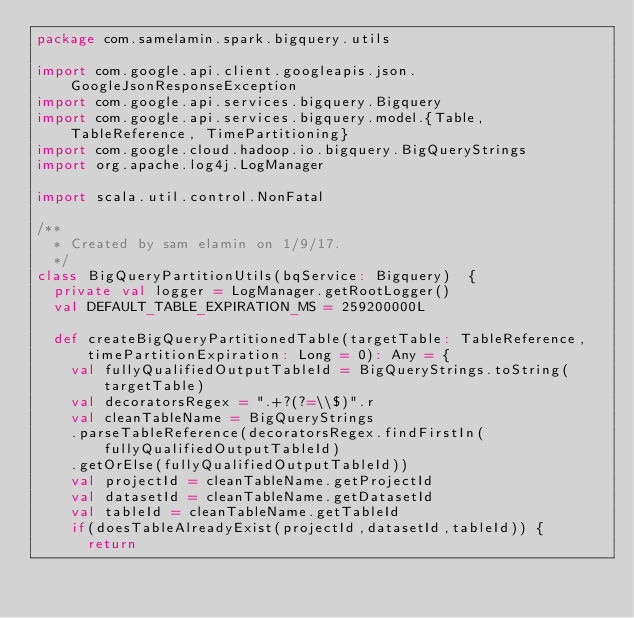<code> <loc_0><loc_0><loc_500><loc_500><_Scala_>package com.samelamin.spark.bigquery.utils

import com.google.api.client.googleapis.json.GoogleJsonResponseException
import com.google.api.services.bigquery.Bigquery
import com.google.api.services.bigquery.model.{Table, TableReference, TimePartitioning}
import com.google.cloud.hadoop.io.bigquery.BigQueryStrings
import org.apache.log4j.LogManager

import scala.util.control.NonFatal

/**
  * Created by sam elamin on 1/9/17.
  */
class BigQueryPartitionUtils(bqService: Bigquery)  {
  private val logger = LogManager.getRootLogger()
  val DEFAULT_TABLE_EXPIRATION_MS = 259200000L

  def createBigQueryPartitionedTable(targetTable: TableReference, timePartitionExpiration: Long = 0): Any = {
    val fullyQualifiedOutputTableId = BigQueryStrings.toString(targetTable)
    val decoratorsRegex = ".+?(?=\\$)".r
    val cleanTableName = BigQueryStrings
    .parseTableReference(decoratorsRegex.findFirstIn(fullyQualifiedOutputTableId)
    .getOrElse(fullyQualifiedOutputTableId))
    val projectId = cleanTableName.getProjectId
    val datasetId = cleanTableName.getDatasetId
    val tableId = cleanTableName.getTableId
    if(doesTableAlreadyExist(projectId,datasetId,tableId)) {
      return</code> 